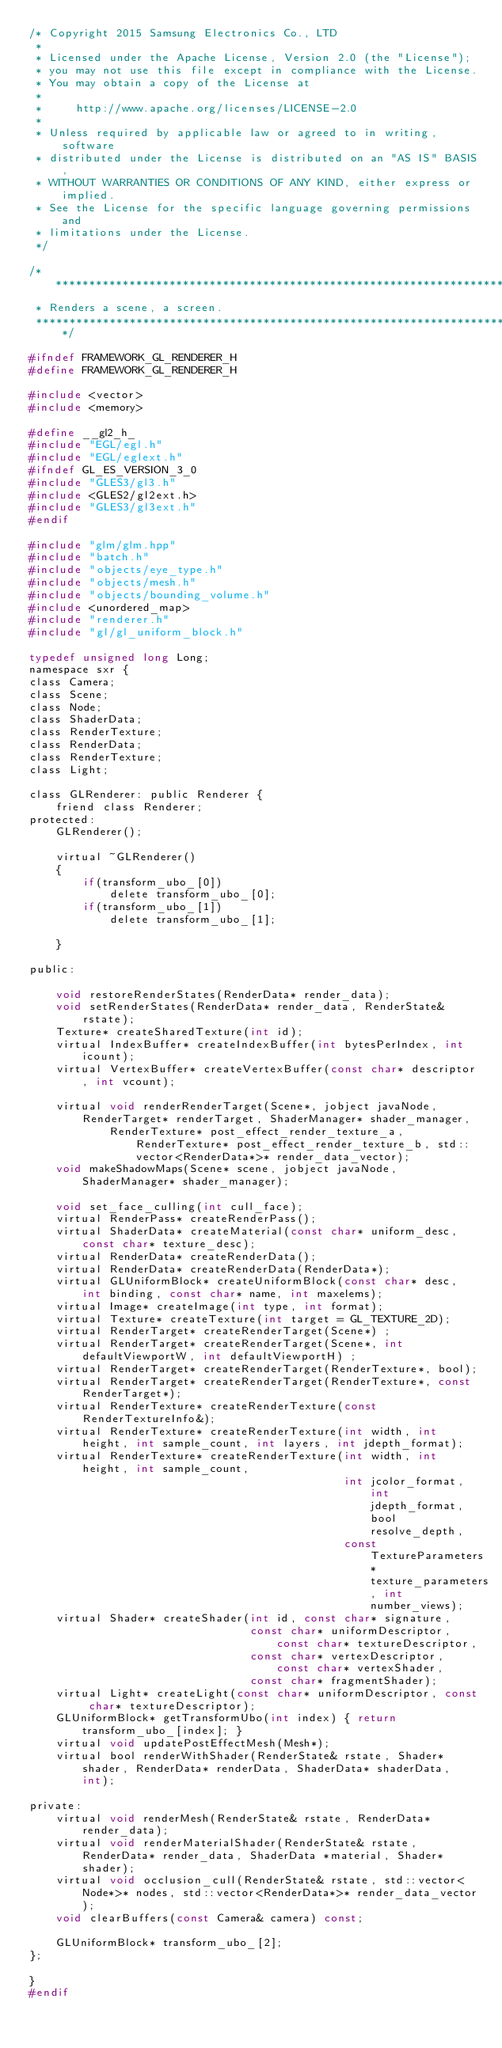<code> <loc_0><loc_0><loc_500><loc_500><_C_>/* Copyright 2015 Samsung Electronics Co., LTD
 *
 * Licensed under the Apache License, Version 2.0 (the "License");
 * you may not use this file except in compliance with the License.
 * You may obtain a copy of the License at
 *
 *     http://www.apache.org/licenses/LICENSE-2.0
 *
 * Unless required by applicable law or agreed to in writing, software
 * distributed under the License is distributed on an "AS IS" BASIS,
 * WITHOUT WARRANTIES OR CONDITIONS OF ANY KIND, either express or implied.
 * See the License for the specific language governing permissions and
 * limitations under the License.
 */

/***************************************************************************
 * Renders a scene, a screen.
 ***************************************************************************/

#ifndef FRAMEWORK_GL_RENDERER_H
#define FRAMEWORK_GL_RENDERER_H

#include <vector>
#include <memory>

#define __gl2_h_
#include "EGL/egl.h"
#include "EGL/eglext.h"
#ifndef GL_ES_VERSION_3_0
#include "GLES3/gl3.h"
#include <GLES2/gl2ext.h>
#include "GLES3/gl3ext.h"
#endif

#include "glm/glm.hpp"
#include "batch.h"
#include "objects/eye_type.h"
#include "objects/mesh.h"
#include "objects/bounding_volume.h"
#include <unordered_map>
#include "renderer.h"
#include "gl/gl_uniform_block.h"

typedef unsigned long Long;
namespace sxr {
class Camera;
class Scene;
class Node;
class ShaderData;
class RenderTexture;
class RenderData;
class RenderTexture;
class Light;

class GLRenderer: public Renderer {
    friend class Renderer;
protected:
    GLRenderer();

    virtual ~GLRenderer()
    {
        if(transform_ubo_[0])
            delete transform_ubo_[0];
        if(transform_ubo_[1])
            delete transform_ubo_[1];

    }

public:

    void restoreRenderStates(RenderData* render_data);
    void setRenderStates(RenderData* render_data, RenderState& rstate);
    Texture* createSharedTexture(int id);
    virtual IndexBuffer* createIndexBuffer(int bytesPerIndex, int icount);
    virtual VertexBuffer* createVertexBuffer(const char* descriptor, int vcount);

    virtual void renderRenderTarget(Scene*, jobject javaNode, RenderTarget* renderTarget, ShaderManager* shader_manager,
            RenderTexture* post_effect_render_texture_a, RenderTexture* post_effect_render_texture_b, std::vector<RenderData*>* render_data_vector);
    void makeShadowMaps(Scene* scene, jobject javaNode, ShaderManager* shader_manager);

    void set_face_culling(int cull_face);
    virtual RenderPass* createRenderPass();
    virtual ShaderData* createMaterial(const char* uniform_desc, const char* texture_desc);
    virtual RenderData* createRenderData();
    virtual RenderData* createRenderData(RenderData*);
    virtual GLUniformBlock* createUniformBlock(const char* desc, int binding, const char* name, int maxelems);
    virtual Image* createImage(int type, int format);
    virtual Texture* createTexture(int target = GL_TEXTURE_2D);
    virtual RenderTarget* createRenderTarget(Scene*) ;
    virtual RenderTarget* createRenderTarget(Scene*, int defaultViewportW, int defaultViewportH) ;
    virtual RenderTarget* createRenderTarget(RenderTexture*, bool);
    virtual RenderTarget* createRenderTarget(RenderTexture*, const RenderTarget*);
    virtual RenderTexture* createRenderTexture(const RenderTextureInfo&);
    virtual RenderTexture* createRenderTexture(int width, int height, int sample_count, int layers, int jdepth_format);
    virtual RenderTexture* createRenderTexture(int width, int height, int sample_count,
                                               int jcolor_format, int jdepth_format, bool resolve_depth,
                                               const TextureParameters* texture_parameters, int number_views);
    virtual Shader* createShader(int id, const char* signature,
                                 const char* uniformDescriptor, const char* textureDescriptor,
                                 const char* vertexDescriptor, const char* vertexShader,
                                 const char* fragmentShader);
    virtual Light* createLight(const char* uniformDescriptor, const char* textureDescriptor);
    GLUniformBlock* getTransformUbo(int index) { return transform_ubo_[index]; }
    virtual void updatePostEffectMesh(Mesh*);
    virtual bool renderWithShader(RenderState& rstate, Shader* shader, RenderData* renderData, ShaderData* shaderData,  int);

private:
    virtual void renderMesh(RenderState& rstate, RenderData* render_data);
    virtual void renderMaterialShader(RenderState& rstate, RenderData* render_data, ShaderData *material, Shader* shader);
    virtual void occlusion_cull(RenderState& rstate, std::vector<Node*>* nodes, std::vector<RenderData*>* render_data_vector);
    void clearBuffers(const Camera& camera) const;

    GLUniformBlock* transform_ubo_[2];
};

}
#endif

</code> 